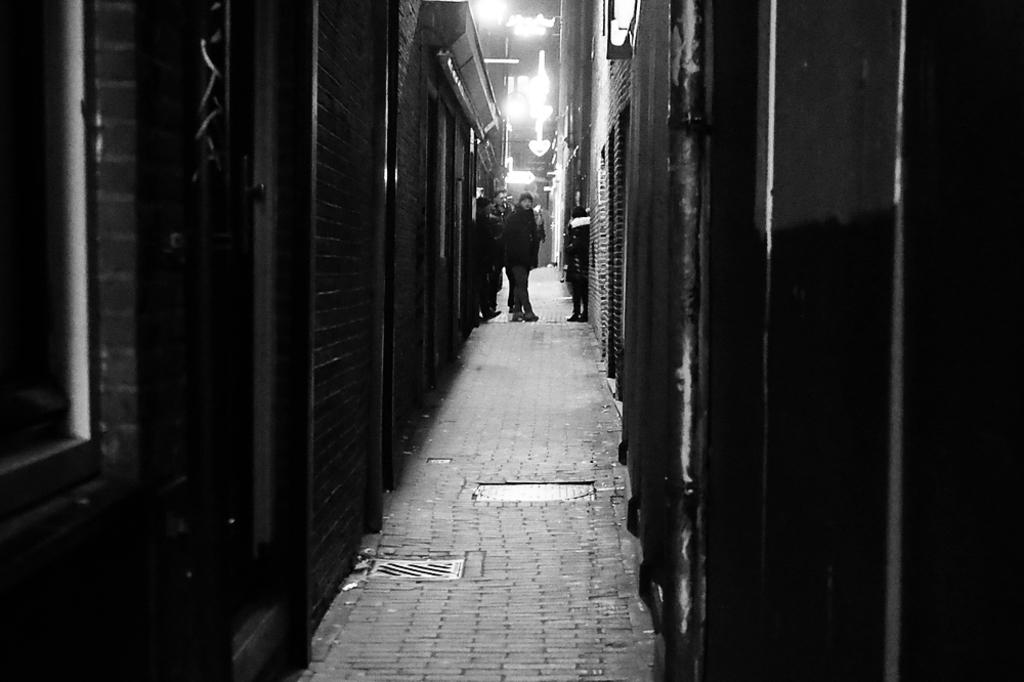What type of openings can be seen in the image? There are windows in the image. What can be seen providing illumination in the image? There are lights in the image. What are the people in the image doing? There are people standing on the ground in the image. What else can be seen in the image besides the windows, lights, and people? There are objects present in the image. What type of learning is taking place in the image? There is no indication of learning or any educational activity in the image. Is the governor present in the image? There is no mention of a governor or any political figure in the image. 